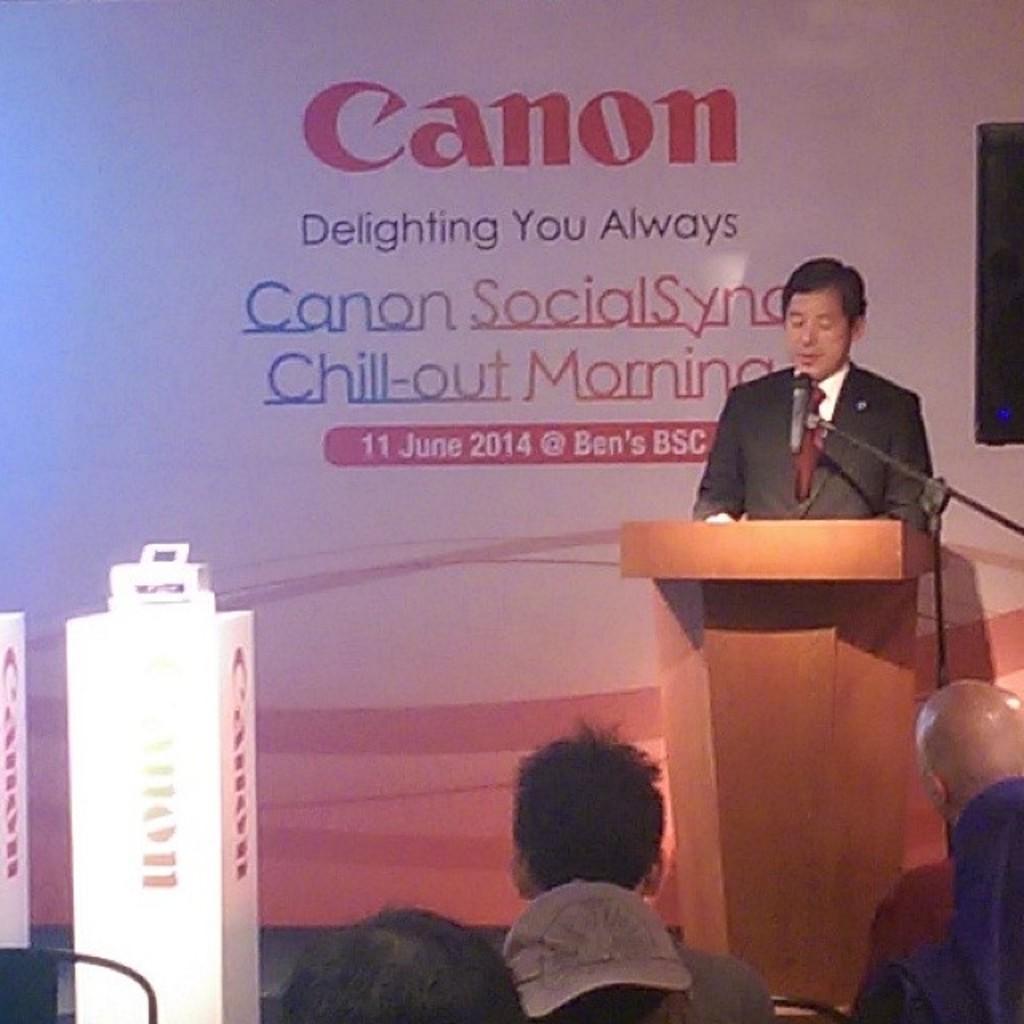In one or two sentences, can you explain what this image depicts? There are some persons present at the bottom of this image and there is one person standing and wearing black color blazer on the right side of this image, and there is a Mic is also present on the right side of this image, and there is a wall poster in the background. 